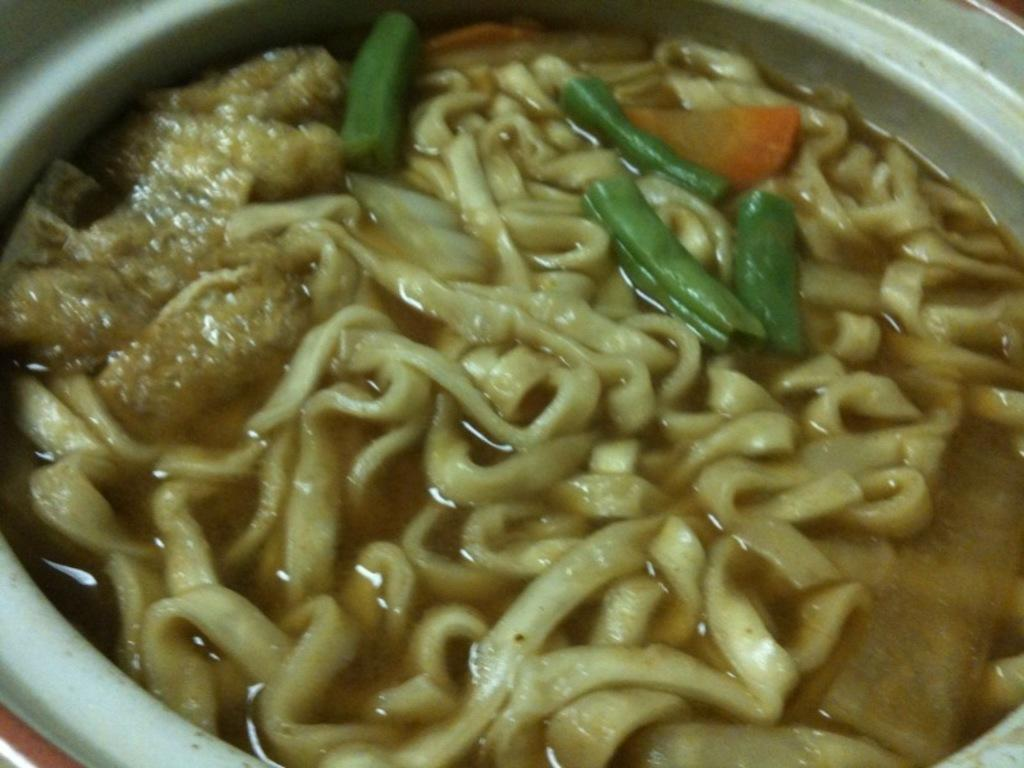What is in the bowl that is visible in the image? There is a bowl in the image, and it contains noodles soup. Can you describe the contents of the bowl in more detail? The bowl contains noodles soup, which typically consists of noodles and a flavorful broth. What type of machine is responsible for creating the anger in the image? There is no machine or anger present in the image; it only features a bowl of noodles soup. 